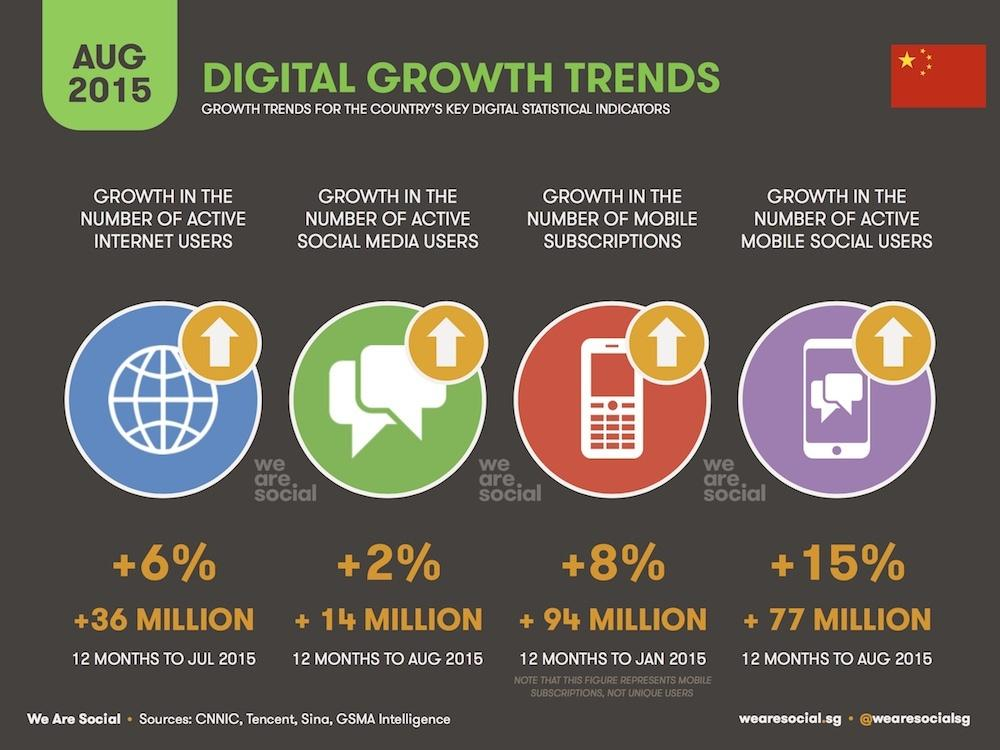List a handful of essential elements in this visual. The number of social media users grew by an increase of 2% from the previous year. The number of mobile subscriptions increased by approximately 94 million. The number of active internet users increased by 6% over a period of time. As of August 2015, the number of active mobile social users had increased by 77 million. 